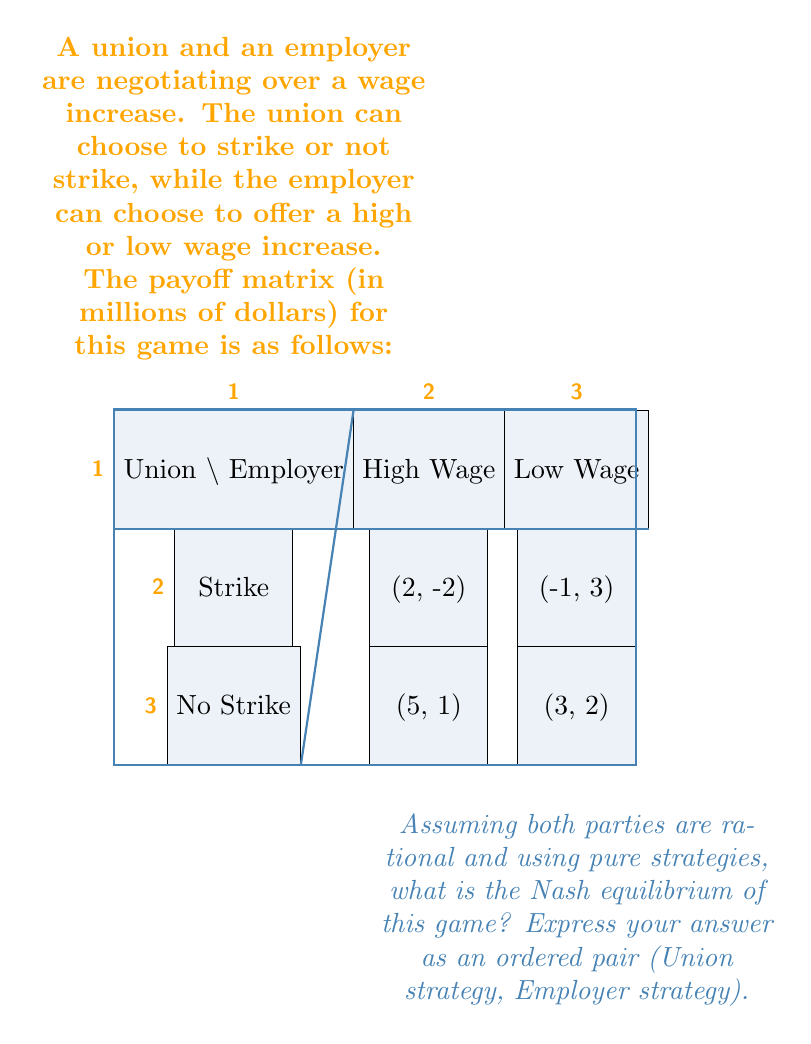Give your solution to this math problem. To find the Nash equilibrium, we need to analyze each player's best response to the other player's strategy:

1. From the Union's perspective:
   - If Employer offers High Wage:
     No Strike payoff (5) > Strike payoff (2)
   - If Employer offers Low Wage:
     Strike payoff (-1) < No Strike payoff (3)

2. From the Employer's perspective:
   - If Union Strikes:
     Low Wage payoff (3) > High Wage payoff (-2)
   - If Union doesn't Strike:
     Low Wage payoff (2) < High Wage payoff (1)

3. To find the Nash equilibrium, we look for a strategy pair where neither player has an incentive to unilaterally change their strategy:

   - If Union chooses No Strike:
     Employer's best response is Low Wage
   - If Employer chooses Low Wage:
     Union's best response is No Strike

4. Therefore, the Nash equilibrium is (No Strike, Low Wage).

This outcome represents a situation where neither party can improve their position by changing their strategy unilaterally. The union won't strike because it would reduce their payoff, and the employer won't offer a high wage because it would reduce their payoff.
Answer: (No Strike, Low Wage) 